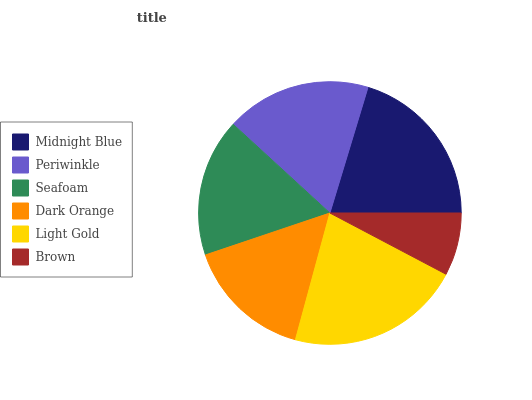Is Brown the minimum?
Answer yes or no. Yes. Is Light Gold the maximum?
Answer yes or no. Yes. Is Periwinkle the minimum?
Answer yes or no. No. Is Periwinkle the maximum?
Answer yes or no. No. Is Midnight Blue greater than Periwinkle?
Answer yes or no. Yes. Is Periwinkle less than Midnight Blue?
Answer yes or no. Yes. Is Periwinkle greater than Midnight Blue?
Answer yes or no. No. Is Midnight Blue less than Periwinkle?
Answer yes or no. No. Is Periwinkle the high median?
Answer yes or no. Yes. Is Seafoam the low median?
Answer yes or no. Yes. Is Midnight Blue the high median?
Answer yes or no. No. Is Midnight Blue the low median?
Answer yes or no. No. 